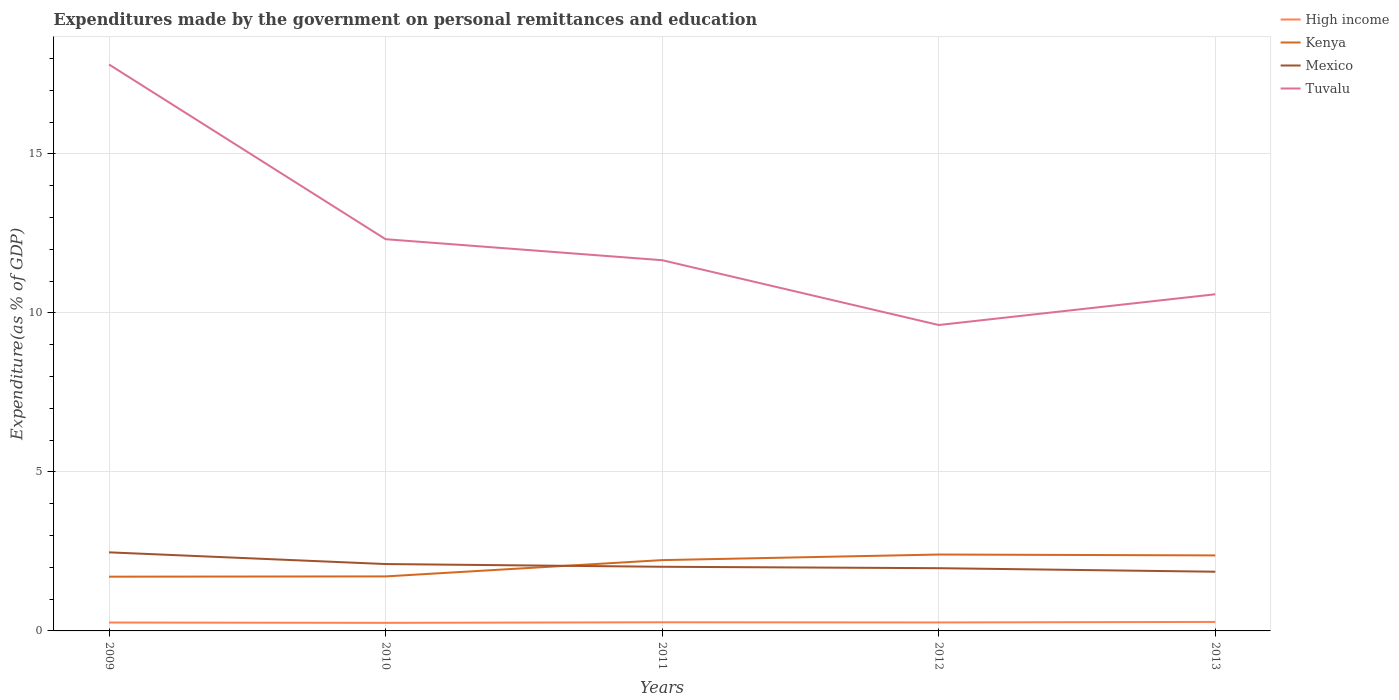How many different coloured lines are there?
Keep it short and to the point. 4. Is the number of lines equal to the number of legend labels?
Give a very brief answer. Yes. Across all years, what is the maximum expenditures made by the government on personal remittances and education in Tuvalu?
Your answer should be very brief. 9.62. In which year was the expenditures made by the government on personal remittances and education in High income maximum?
Your answer should be compact. 2010. What is the total expenditures made by the government on personal remittances and education in Mexico in the graph?
Give a very brief answer. 0.5. What is the difference between the highest and the second highest expenditures made by the government on personal remittances and education in Kenya?
Make the answer very short. 0.7. What is the difference between two consecutive major ticks on the Y-axis?
Provide a succinct answer. 5. Are the values on the major ticks of Y-axis written in scientific E-notation?
Keep it short and to the point. No. Does the graph contain any zero values?
Your answer should be very brief. No. How are the legend labels stacked?
Keep it short and to the point. Vertical. What is the title of the graph?
Offer a very short reply. Expenditures made by the government on personal remittances and education. What is the label or title of the Y-axis?
Keep it short and to the point. Expenditure(as % of GDP). What is the Expenditure(as % of GDP) of High income in 2009?
Offer a terse response. 0.26. What is the Expenditure(as % of GDP) of Kenya in 2009?
Your response must be concise. 1.71. What is the Expenditure(as % of GDP) of Mexico in 2009?
Give a very brief answer. 2.47. What is the Expenditure(as % of GDP) in Tuvalu in 2009?
Ensure brevity in your answer.  17.81. What is the Expenditure(as % of GDP) in High income in 2010?
Ensure brevity in your answer.  0.25. What is the Expenditure(as % of GDP) of Kenya in 2010?
Make the answer very short. 1.71. What is the Expenditure(as % of GDP) in Mexico in 2010?
Make the answer very short. 2.1. What is the Expenditure(as % of GDP) in Tuvalu in 2010?
Make the answer very short. 12.32. What is the Expenditure(as % of GDP) of High income in 2011?
Offer a very short reply. 0.27. What is the Expenditure(as % of GDP) in Kenya in 2011?
Your answer should be very brief. 2.23. What is the Expenditure(as % of GDP) in Mexico in 2011?
Provide a succinct answer. 2.02. What is the Expenditure(as % of GDP) of Tuvalu in 2011?
Give a very brief answer. 11.66. What is the Expenditure(as % of GDP) in High income in 2012?
Offer a terse response. 0.27. What is the Expenditure(as % of GDP) in Kenya in 2012?
Provide a short and direct response. 2.4. What is the Expenditure(as % of GDP) of Mexico in 2012?
Offer a very short reply. 1.97. What is the Expenditure(as % of GDP) of Tuvalu in 2012?
Offer a terse response. 9.62. What is the Expenditure(as % of GDP) in High income in 2013?
Give a very brief answer. 0.28. What is the Expenditure(as % of GDP) in Kenya in 2013?
Your response must be concise. 2.37. What is the Expenditure(as % of GDP) of Mexico in 2013?
Ensure brevity in your answer.  1.86. What is the Expenditure(as % of GDP) of Tuvalu in 2013?
Your answer should be very brief. 10.59. Across all years, what is the maximum Expenditure(as % of GDP) in High income?
Make the answer very short. 0.28. Across all years, what is the maximum Expenditure(as % of GDP) in Kenya?
Offer a terse response. 2.4. Across all years, what is the maximum Expenditure(as % of GDP) of Mexico?
Your response must be concise. 2.47. Across all years, what is the maximum Expenditure(as % of GDP) in Tuvalu?
Keep it short and to the point. 17.81. Across all years, what is the minimum Expenditure(as % of GDP) in High income?
Keep it short and to the point. 0.25. Across all years, what is the minimum Expenditure(as % of GDP) in Kenya?
Offer a terse response. 1.71. Across all years, what is the minimum Expenditure(as % of GDP) in Mexico?
Ensure brevity in your answer.  1.86. Across all years, what is the minimum Expenditure(as % of GDP) of Tuvalu?
Make the answer very short. 9.62. What is the total Expenditure(as % of GDP) of High income in the graph?
Give a very brief answer. 1.34. What is the total Expenditure(as % of GDP) of Kenya in the graph?
Your response must be concise. 10.42. What is the total Expenditure(as % of GDP) of Mexico in the graph?
Offer a terse response. 10.43. What is the total Expenditure(as % of GDP) in Tuvalu in the graph?
Your answer should be very brief. 61.99. What is the difference between the Expenditure(as % of GDP) of High income in 2009 and that in 2010?
Provide a short and direct response. 0.01. What is the difference between the Expenditure(as % of GDP) in Kenya in 2009 and that in 2010?
Make the answer very short. -0.01. What is the difference between the Expenditure(as % of GDP) of Mexico in 2009 and that in 2010?
Your answer should be compact. 0.37. What is the difference between the Expenditure(as % of GDP) of Tuvalu in 2009 and that in 2010?
Offer a very short reply. 5.49. What is the difference between the Expenditure(as % of GDP) of High income in 2009 and that in 2011?
Keep it short and to the point. -0.01. What is the difference between the Expenditure(as % of GDP) of Kenya in 2009 and that in 2011?
Offer a very short reply. -0.52. What is the difference between the Expenditure(as % of GDP) in Mexico in 2009 and that in 2011?
Provide a short and direct response. 0.45. What is the difference between the Expenditure(as % of GDP) in Tuvalu in 2009 and that in 2011?
Your answer should be compact. 6.15. What is the difference between the Expenditure(as % of GDP) of High income in 2009 and that in 2012?
Offer a very short reply. -0. What is the difference between the Expenditure(as % of GDP) in Kenya in 2009 and that in 2012?
Ensure brevity in your answer.  -0.7. What is the difference between the Expenditure(as % of GDP) of Mexico in 2009 and that in 2012?
Offer a very short reply. 0.5. What is the difference between the Expenditure(as % of GDP) of Tuvalu in 2009 and that in 2012?
Your answer should be very brief. 8.19. What is the difference between the Expenditure(as % of GDP) in High income in 2009 and that in 2013?
Your answer should be very brief. -0.02. What is the difference between the Expenditure(as % of GDP) of Kenya in 2009 and that in 2013?
Offer a very short reply. -0.67. What is the difference between the Expenditure(as % of GDP) of Mexico in 2009 and that in 2013?
Your answer should be very brief. 0.61. What is the difference between the Expenditure(as % of GDP) of Tuvalu in 2009 and that in 2013?
Your answer should be very brief. 7.23. What is the difference between the Expenditure(as % of GDP) of High income in 2010 and that in 2011?
Ensure brevity in your answer.  -0.02. What is the difference between the Expenditure(as % of GDP) of Kenya in 2010 and that in 2011?
Offer a terse response. -0.51. What is the difference between the Expenditure(as % of GDP) in Mexico in 2010 and that in 2011?
Offer a terse response. 0.09. What is the difference between the Expenditure(as % of GDP) in Tuvalu in 2010 and that in 2011?
Ensure brevity in your answer.  0.66. What is the difference between the Expenditure(as % of GDP) in High income in 2010 and that in 2012?
Keep it short and to the point. -0.01. What is the difference between the Expenditure(as % of GDP) in Kenya in 2010 and that in 2012?
Your answer should be very brief. -0.69. What is the difference between the Expenditure(as % of GDP) of Mexico in 2010 and that in 2012?
Your response must be concise. 0.13. What is the difference between the Expenditure(as % of GDP) of Tuvalu in 2010 and that in 2012?
Provide a succinct answer. 2.7. What is the difference between the Expenditure(as % of GDP) of High income in 2010 and that in 2013?
Offer a terse response. -0.03. What is the difference between the Expenditure(as % of GDP) of Kenya in 2010 and that in 2013?
Give a very brief answer. -0.66. What is the difference between the Expenditure(as % of GDP) in Mexico in 2010 and that in 2013?
Offer a very short reply. 0.24. What is the difference between the Expenditure(as % of GDP) in Tuvalu in 2010 and that in 2013?
Offer a very short reply. 1.73. What is the difference between the Expenditure(as % of GDP) in High income in 2011 and that in 2012?
Offer a terse response. 0.01. What is the difference between the Expenditure(as % of GDP) in Kenya in 2011 and that in 2012?
Your response must be concise. -0.18. What is the difference between the Expenditure(as % of GDP) in Mexico in 2011 and that in 2012?
Your answer should be compact. 0.04. What is the difference between the Expenditure(as % of GDP) of Tuvalu in 2011 and that in 2012?
Offer a very short reply. 2.04. What is the difference between the Expenditure(as % of GDP) of High income in 2011 and that in 2013?
Provide a succinct answer. -0.01. What is the difference between the Expenditure(as % of GDP) in Kenya in 2011 and that in 2013?
Provide a succinct answer. -0.15. What is the difference between the Expenditure(as % of GDP) in Mexico in 2011 and that in 2013?
Provide a short and direct response. 0.16. What is the difference between the Expenditure(as % of GDP) in Tuvalu in 2011 and that in 2013?
Offer a terse response. 1.07. What is the difference between the Expenditure(as % of GDP) in High income in 2012 and that in 2013?
Provide a succinct answer. -0.02. What is the difference between the Expenditure(as % of GDP) in Kenya in 2012 and that in 2013?
Ensure brevity in your answer.  0.03. What is the difference between the Expenditure(as % of GDP) in Tuvalu in 2012 and that in 2013?
Your response must be concise. -0.97. What is the difference between the Expenditure(as % of GDP) of High income in 2009 and the Expenditure(as % of GDP) of Kenya in 2010?
Your answer should be very brief. -1.45. What is the difference between the Expenditure(as % of GDP) of High income in 2009 and the Expenditure(as % of GDP) of Mexico in 2010?
Offer a very short reply. -1.84. What is the difference between the Expenditure(as % of GDP) in High income in 2009 and the Expenditure(as % of GDP) in Tuvalu in 2010?
Your response must be concise. -12.05. What is the difference between the Expenditure(as % of GDP) of Kenya in 2009 and the Expenditure(as % of GDP) of Mexico in 2010?
Your response must be concise. -0.4. What is the difference between the Expenditure(as % of GDP) of Kenya in 2009 and the Expenditure(as % of GDP) of Tuvalu in 2010?
Your answer should be very brief. -10.61. What is the difference between the Expenditure(as % of GDP) of Mexico in 2009 and the Expenditure(as % of GDP) of Tuvalu in 2010?
Your answer should be compact. -9.85. What is the difference between the Expenditure(as % of GDP) of High income in 2009 and the Expenditure(as % of GDP) of Kenya in 2011?
Your response must be concise. -1.96. What is the difference between the Expenditure(as % of GDP) of High income in 2009 and the Expenditure(as % of GDP) of Mexico in 2011?
Make the answer very short. -1.75. What is the difference between the Expenditure(as % of GDP) in High income in 2009 and the Expenditure(as % of GDP) in Tuvalu in 2011?
Ensure brevity in your answer.  -11.39. What is the difference between the Expenditure(as % of GDP) of Kenya in 2009 and the Expenditure(as % of GDP) of Mexico in 2011?
Your answer should be compact. -0.31. What is the difference between the Expenditure(as % of GDP) of Kenya in 2009 and the Expenditure(as % of GDP) of Tuvalu in 2011?
Keep it short and to the point. -9.95. What is the difference between the Expenditure(as % of GDP) in Mexico in 2009 and the Expenditure(as % of GDP) in Tuvalu in 2011?
Make the answer very short. -9.19. What is the difference between the Expenditure(as % of GDP) of High income in 2009 and the Expenditure(as % of GDP) of Kenya in 2012?
Your answer should be compact. -2.14. What is the difference between the Expenditure(as % of GDP) of High income in 2009 and the Expenditure(as % of GDP) of Mexico in 2012?
Your answer should be very brief. -1.71. What is the difference between the Expenditure(as % of GDP) of High income in 2009 and the Expenditure(as % of GDP) of Tuvalu in 2012?
Your answer should be very brief. -9.36. What is the difference between the Expenditure(as % of GDP) in Kenya in 2009 and the Expenditure(as % of GDP) in Mexico in 2012?
Offer a terse response. -0.27. What is the difference between the Expenditure(as % of GDP) of Kenya in 2009 and the Expenditure(as % of GDP) of Tuvalu in 2012?
Your response must be concise. -7.91. What is the difference between the Expenditure(as % of GDP) of Mexico in 2009 and the Expenditure(as % of GDP) of Tuvalu in 2012?
Give a very brief answer. -7.15. What is the difference between the Expenditure(as % of GDP) in High income in 2009 and the Expenditure(as % of GDP) in Kenya in 2013?
Keep it short and to the point. -2.11. What is the difference between the Expenditure(as % of GDP) in High income in 2009 and the Expenditure(as % of GDP) in Mexico in 2013?
Your answer should be compact. -1.6. What is the difference between the Expenditure(as % of GDP) in High income in 2009 and the Expenditure(as % of GDP) in Tuvalu in 2013?
Keep it short and to the point. -10.32. What is the difference between the Expenditure(as % of GDP) in Kenya in 2009 and the Expenditure(as % of GDP) in Mexico in 2013?
Offer a very short reply. -0.16. What is the difference between the Expenditure(as % of GDP) of Kenya in 2009 and the Expenditure(as % of GDP) of Tuvalu in 2013?
Keep it short and to the point. -8.88. What is the difference between the Expenditure(as % of GDP) of Mexico in 2009 and the Expenditure(as % of GDP) of Tuvalu in 2013?
Offer a very short reply. -8.12. What is the difference between the Expenditure(as % of GDP) in High income in 2010 and the Expenditure(as % of GDP) in Kenya in 2011?
Ensure brevity in your answer.  -1.97. What is the difference between the Expenditure(as % of GDP) of High income in 2010 and the Expenditure(as % of GDP) of Mexico in 2011?
Offer a terse response. -1.76. What is the difference between the Expenditure(as % of GDP) in High income in 2010 and the Expenditure(as % of GDP) in Tuvalu in 2011?
Offer a very short reply. -11.4. What is the difference between the Expenditure(as % of GDP) of Kenya in 2010 and the Expenditure(as % of GDP) of Mexico in 2011?
Offer a terse response. -0.3. What is the difference between the Expenditure(as % of GDP) in Kenya in 2010 and the Expenditure(as % of GDP) in Tuvalu in 2011?
Offer a very short reply. -9.94. What is the difference between the Expenditure(as % of GDP) in Mexico in 2010 and the Expenditure(as % of GDP) in Tuvalu in 2011?
Make the answer very short. -9.55. What is the difference between the Expenditure(as % of GDP) in High income in 2010 and the Expenditure(as % of GDP) in Kenya in 2012?
Provide a short and direct response. -2.15. What is the difference between the Expenditure(as % of GDP) in High income in 2010 and the Expenditure(as % of GDP) in Mexico in 2012?
Your answer should be compact. -1.72. What is the difference between the Expenditure(as % of GDP) of High income in 2010 and the Expenditure(as % of GDP) of Tuvalu in 2012?
Your answer should be compact. -9.37. What is the difference between the Expenditure(as % of GDP) of Kenya in 2010 and the Expenditure(as % of GDP) of Mexico in 2012?
Offer a very short reply. -0.26. What is the difference between the Expenditure(as % of GDP) in Kenya in 2010 and the Expenditure(as % of GDP) in Tuvalu in 2012?
Offer a terse response. -7.91. What is the difference between the Expenditure(as % of GDP) of Mexico in 2010 and the Expenditure(as % of GDP) of Tuvalu in 2012?
Your answer should be very brief. -7.52. What is the difference between the Expenditure(as % of GDP) of High income in 2010 and the Expenditure(as % of GDP) of Kenya in 2013?
Offer a very short reply. -2.12. What is the difference between the Expenditure(as % of GDP) in High income in 2010 and the Expenditure(as % of GDP) in Mexico in 2013?
Offer a terse response. -1.61. What is the difference between the Expenditure(as % of GDP) in High income in 2010 and the Expenditure(as % of GDP) in Tuvalu in 2013?
Ensure brevity in your answer.  -10.33. What is the difference between the Expenditure(as % of GDP) of Kenya in 2010 and the Expenditure(as % of GDP) of Mexico in 2013?
Keep it short and to the point. -0.15. What is the difference between the Expenditure(as % of GDP) of Kenya in 2010 and the Expenditure(as % of GDP) of Tuvalu in 2013?
Ensure brevity in your answer.  -8.87. What is the difference between the Expenditure(as % of GDP) of Mexico in 2010 and the Expenditure(as % of GDP) of Tuvalu in 2013?
Provide a succinct answer. -8.48. What is the difference between the Expenditure(as % of GDP) in High income in 2011 and the Expenditure(as % of GDP) in Kenya in 2012?
Ensure brevity in your answer.  -2.13. What is the difference between the Expenditure(as % of GDP) in High income in 2011 and the Expenditure(as % of GDP) in Mexico in 2012?
Make the answer very short. -1.7. What is the difference between the Expenditure(as % of GDP) in High income in 2011 and the Expenditure(as % of GDP) in Tuvalu in 2012?
Ensure brevity in your answer.  -9.35. What is the difference between the Expenditure(as % of GDP) of Kenya in 2011 and the Expenditure(as % of GDP) of Mexico in 2012?
Provide a succinct answer. 0.25. What is the difference between the Expenditure(as % of GDP) in Kenya in 2011 and the Expenditure(as % of GDP) in Tuvalu in 2012?
Provide a short and direct response. -7.39. What is the difference between the Expenditure(as % of GDP) in Mexico in 2011 and the Expenditure(as % of GDP) in Tuvalu in 2012?
Provide a succinct answer. -7.6. What is the difference between the Expenditure(as % of GDP) in High income in 2011 and the Expenditure(as % of GDP) in Kenya in 2013?
Your response must be concise. -2.1. What is the difference between the Expenditure(as % of GDP) in High income in 2011 and the Expenditure(as % of GDP) in Mexico in 2013?
Provide a succinct answer. -1.59. What is the difference between the Expenditure(as % of GDP) in High income in 2011 and the Expenditure(as % of GDP) in Tuvalu in 2013?
Your response must be concise. -10.31. What is the difference between the Expenditure(as % of GDP) of Kenya in 2011 and the Expenditure(as % of GDP) of Mexico in 2013?
Offer a terse response. 0.37. What is the difference between the Expenditure(as % of GDP) in Kenya in 2011 and the Expenditure(as % of GDP) in Tuvalu in 2013?
Provide a short and direct response. -8.36. What is the difference between the Expenditure(as % of GDP) of Mexico in 2011 and the Expenditure(as % of GDP) of Tuvalu in 2013?
Offer a very short reply. -8.57. What is the difference between the Expenditure(as % of GDP) in High income in 2012 and the Expenditure(as % of GDP) in Kenya in 2013?
Provide a succinct answer. -2.11. What is the difference between the Expenditure(as % of GDP) of High income in 2012 and the Expenditure(as % of GDP) of Mexico in 2013?
Your answer should be compact. -1.6. What is the difference between the Expenditure(as % of GDP) of High income in 2012 and the Expenditure(as % of GDP) of Tuvalu in 2013?
Your answer should be compact. -10.32. What is the difference between the Expenditure(as % of GDP) in Kenya in 2012 and the Expenditure(as % of GDP) in Mexico in 2013?
Ensure brevity in your answer.  0.54. What is the difference between the Expenditure(as % of GDP) in Kenya in 2012 and the Expenditure(as % of GDP) in Tuvalu in 2013?
Your answer should be compact. -8.18. What is the difference between the Expenditure(as % of GDP) of Mexico in 2012 and the Expenditure(as % of GDP) of Tuvalu in 2013?
Make the answer very short. -8.61. What is the average Expenditure(as % of GDP) in High income per year?
Keep it short and to the point. 0.27. What is the average Expenditure(as % of GDP) in Kenya per year?
Ensure brevity in your answer.  2.08. What is the average Expenditure(as % of GDP) of Mexico per year?
Give a very brief answer. 2.09. What is the average Expenditure(as % of GDP) of Tuvalu per year?
Offer a terse response. 12.4. In the year 2009, what is the difference between the Expenditure(as % of GDP) in High income and Expenditure(as % of GDP) in Kenya?
Provide a short and direct response. -1.44. In the year 2009, what is the difference between the Expenditure(as % of GDP) in High income and Expenditure(as % of GDP) in Mexico?
Your answer should be compact. -2.21. In the year 2009, what is the difference between the Expenditure(as % of GDP) of High income and Expenditure(as % of GDP) of Tuvalu?
Keep it short and to the point. -17.55. In the year 2009, what is the difference between the Expenditure(as % of GDP) of Kenya and Expenditure(as % of GDP) of Mexico?
Provide a succinct answer. -0.77. In the year 2009, what is the difference between the Expenditure(as % of GDP) of Kenya and Expenditure(as % of GDP) of Tuvalu?
Your answer should be very brief. -16.11. In the year 2009, what is the difference between the Expenditure(as % of GDP) of Mexico and Expenditure(as % of GDP) of Tuvalu?
Offer a very short reply. -15.34. In the year 2010, what is the difference between the Expenditure(as % of GDP) in High income and Expenditure(as % of GDP) in Kenya?
Make the answer very short. -1.46. In the year 2010, what is the difference between the Expenditure(as % of GDP) of High income and Expenditure(as % of GDP) of Mexico?
Your response must be concise. -1.85. In the year 2010, what is the difference between the Expenditure(as % of GDP) of High income and Expenditure(as % of GDP) of Tuvalu?
Keep it short and to the point. -12.06. In the year 2010, what is the difference between the Expenditure(as % of GDP) in Kenya and Expenditure(as % of GDP) in Mexico?
Your response must be concise. -0.39. In the year 2010, what is the difference between the Expenditure(as % of GDP) of Kenya and Expenditure(as % of GDP) of Tuvalu?
Offer a very short reply. -10.6. In the year 2010, what is the difference between the Expenditure(as % of GDP) in Mexico and Expenditure(as % of GDP) in Tuvalu?
Give a very brief answer. -10.21. In the year 2011, what is the difference between the Expenditure(as % of GDP) of High income and Expenditure(as % of GDP) of Kenya?
Offer a terse response. -1.95. In the year 2011, what is the difference between the Expenditure(as % of GDP) of High income and Expenditure(as % of GDP) of Mexico?
Ensure brevity in your answer.  -1.75. In the year 2011, what is the difference between the Expenditure(as % of GDP) in High income and Expenditure(as % of GDP) in Tuvalu?
Your answer should be compact. -11.39. In the year 2011, what is the difference between the Expenditure(as % of GDP) in Kenya and Expenditure(as % of GDP) in Mexico?
Your answer should be very brief. 0.21. In the year 2011, what is the difference between the Expenditure(as % of GDP) in Kenya and Expenditure(as % of GDP) in Tuvalu?
Your response must be concise. -9.43. In the year 2011, what is the difference between the Expenditure(as % of GDP) of Mexico and Expenditure(as % of GDP) of Tuvalu?
Provide a short and direct response. -9.64. In the year 2012, what is the difference between the Expenditure(as % of GDP) in High income and Expenditure(as % of GDP) in Kenya?
Make the answer very short. -2.14. In the year 2012, what is the difference between the Expenditure(as % of GDP) in High income and Expenditure(as % of GDP) in Mexico?
Ensure brevity in your answer.  -1.71. In the year 2012, what is the difference between the Expenditure(as % of GDP) in High income and Expenditure(as % of GDP) in Tuvalu?
Make the answer very short. -9.35. In the year 2012, what is the difference between the Expenditure(as % of GDP) of Kenya and Expenditure(as % of GDP) of Mexico?
Ensure brevity in your answer.  0.43. In the year 2012, what is the difference between the Expenditure(as % of GDP) in Kenya and Expenditure(as % of GDP) in Tuvalu?
Offer a very short reply. -7.22. In the year 2012, what is the difference between the Expenditure(as % of GDP) of Mexico and Expenditure(as % of GDP) of Tuvalu?
Offer a terse response. -7.65. In the year 2013, what is the difference between the Expenditure(as % of GDP) of High income and Expenditure(as % of GDP) of Kenya?
Your answer should be very brief. -2.09. In the year 2013, what is the difference between the Expenditure(as % of GDP) in High income and Expenditure(as % of GDP) in Mexico?
Keep it short and to the point. -1.58. In the year 2013, what is the difference between the Expenditure(as % of GDP) of High income and Expenditure(as % of GDP) of Tuvalu?
Give a very brief answer. -10.3. In the year 2013, what is the difference between the Expenditure(as % of GDP) in Kenya and Expenditure(as % of GDP) in Mexico?
Give a very brief answer. 0.51. In the year 2013, what is the difference between the Expenditure(as % of GDP) in Kenya and Expenditure(as % of GDP) in Tuvalu?
Provide a succinct answer. -8.21. In the year 2013, what is the difference between the Expenditure(as % of GDP) in Mexico and Expenditure(as % of GDP) in Tuvalu?
Provide a succinct answer. -8.72. What is the ratio of the Expenditure(as % of GDP) of High income in 2009 to that in 2010?
Your answer should be very brief. 1.04. What is the ratio of the Expenditure(as % of GDP) in Kenya in 2009 to that in 2010?
Offer a very short reply. 0.99. What is the ratio of the Expenditure(as % of GDP) in Mexico in 2009 to that in 2010?
Keep it short and to the point. 1.18. What is the ratio of the Expenditure(as % of GDP) in Tuvalu in 2009 to that in 2010?
Your answer should be very brief. 1.45. What is the ratio of the Expenditure(as % of GDP) of High income in 2009 to that in 2011?
Ensure brevity in your answer.  0.97. What is the ratio of the Expenditure(as % of GDP) of Kenya in 2009 to that in 2011?
Give a very brief answer. 0.77. What is the ratio of the Expenditure(as % of GDP) of Mexico in 2009 to that in 2011?
Your response must be concise. 1.23. What is the ratio of the Expenditure(as % of GDP) in Tuvalu in 2009 to that in 2011?
Ensure brevity in your answer.  1.53. What is the ratio of the Expenditure(as % of GDP) in High income in 2009 to that in 2012?
Your answer should be very brief. 0.99. What is the ratio of the Expenditure(as % of GDP) in Kenya in 2009 to that in 2012?
Keep it short and to the point. 0.71. What is the ratio of the Expenditure(as % of GDP) of Mexico in 2009 to that in 2012?
Offer a terse response. 1.25. What is the ratio of the Expenditure(as % of GDP) in Tuvalu in 2009 to that in 2012?
Offer a terse response. 1.85. What is the ratio of the Expenditure(as % of GDP) of High income in 2009 to that in 2013?
Your answer should be compact. 0.93. What is the ratio of the Expenditure(as % of GDP) in Kenya in 2009 to that in 2013?
Ensure brevity in your answer.  0.72. What is the ratio of the Expenditure(as % of GDP) in Mexico in 2009 to that in 2013?
Offer a terse response. 1.33. What is the ratio of the Expenditure(as % of GDP) of Tuvalu in 2009 to that in 2013?
Make the answer very short. 1.68. What is the ratio of the Expenditure(as % of GDP) of High income in 2010 to that in 2011?
Your response must be concise. 0.94. What is the ratio of the Expenditure(as % of GDP) in Kenya in 2010 to that in 2011?
Your answer should be compact. 0.77. What is the ratio of the Expenditure(as % of GDP) in Mexico in 2010 to that in 2011?
Your response must be concise. 1.04. What is the ratio of the Expenditure(as % of GDP) of Tuvalu in 2010 to that in 2011?
Offer a very short reply. 1.06. What is the ratio of the Expenditure(as % of GDP) of High income in 2010 to that in 2012?
Your answer should be very brief. 0.95. What is the ratio of the Expenditure(as % of GDP) of Kenya in 2010 to that in 2012?
Offer a very short reply. 0.71. What is the ratio of the Expenditure(as % of GDP) of Mexico in 2010 to that in 2012?
Make the answer very short. 1.07. What is the ratio of the Expenditure(as % of GDP) of Tuvalu in 2010 to that in 2012?
Give a very brief answer. 1.28. What is the ratio of the Expenditure(as % of GDP) of High income in 2010 to that in 2013?
Offer a very short reply. 0.9. What is the ratio of the Expenditure(as % of GDP) in Kenya in 2010 to that in 2013?
Your response must be concise. 0.72. What is the ratio of the Expenditure(as % of GDP) of Mexico in 2010 to that in 2013?
Your response must be concise. 1.13. What is the ratio of the Expenditure(as % of GDP) of Tuvalu in 2010 to that in 2013?
Ensure brevity in your answer.  1.16. What is the ratio of the Expenditure(as % of GDP) of High income in 2011 to that in 2012?
Give a very brief answer. 1.02. What is the ratio of the Expenditure(as % of GDP) of Kenya in 2011 to that in 2012?
Offer a very short reply. 0.93. What is the ratio of the Expenditure(as % of GDP) of Mexico in 2011 to that in 2012?
Provide a short and direct response. 1.02. What is the ratio of the Expenditure(as % of GDP) of Tuvalu in 2011 to that in 2012?
Offer a terse response. 1.21. What is the ratio of the Expenditure(as % of GDP) of High income in 2011 to that in 2013?
Provide a succinct answer. 0.96. What is the ratio of the Expenditure(as % of GDP) of Kenya in 2011 to that in 2013?
Provide a succinct answer. 0.94. What is the ratio of the Expenditure(as % of GDP) of Mexico in 2011 to that in 2013?
Make the answer very short. 1.08. What is the ratio of the Expenditure(as % of GDP) of Tuvalu in 2011 to that in 2013?
Provide a short and direct response. 1.1. What is the ratio of the Expenditure(as % of GDP) in High income in 2012 to that in 2013?
Your answer should be compact. 0.94. What is the ratio of the Expenditure(as % of GDP) of Kenya in 2012 to that in 2013?
Provide a short and direct response. 1.01. What is the ratio of the Expenditure(as % of GDP) of Mexico in 2012 to that in 2013?
Offer a very short reply. 1.06. What is the ratio of the Expenditure(as % of GDP) of Tuvalu in 2012 to that in 2013?
Provide a succinct answer. 0.91. What is the difference between the highest and the second highest Expenditure(as % of GDP) of High income?
Give a very brief answer. 0.01. What is the difference between the highest and the second highest Expenditure(as % of GDP) of Kenya?
Your response must be concise. 0.03. What is the difference between the highest and the second highest Expenditure(as % of GDP) of Mexico?
Offer a very short reply. 0.37. What is the difference between the highest and the second highest Expenditure(as % of GDP) in Tuvalu?
Your answer should be very brief. 5.49. What is the difference between the highest and the lowest Expenditure(as % of GDP) of High income?
Your answer should be very brief. 0.03. What is the difference between the highest and the lowest Expenditure(as % of GDP) in Kenya?
Offer a terse response. 0.7. What is the difference between the highest and the lowest Expenditure(as % of GDP) of Mexico?
Provide a succinct answer. 0.61. What is the difference between the highest and the lowest Expenditure(as % of GDP) in Tuvalu?
Your answer should be very brief. 8.19. 